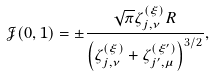<formula> <loc_0><loc_0><loc_500><loc_500>\mathcal { J } ( 0 , 1 ) = \pm \frac { \sqrt { \pi } \zeta _ { j , \nu } ^ { ( \xi ) } R } { \left ( \zeta _ { j , \nu } ^ { ( \xi ) } + \zeta _ { j ^ { \prime } , \mu } ^ { ( \xi ^ { \prime } ) } \right ) ^ { 3 / 2 } } ,</formula> 